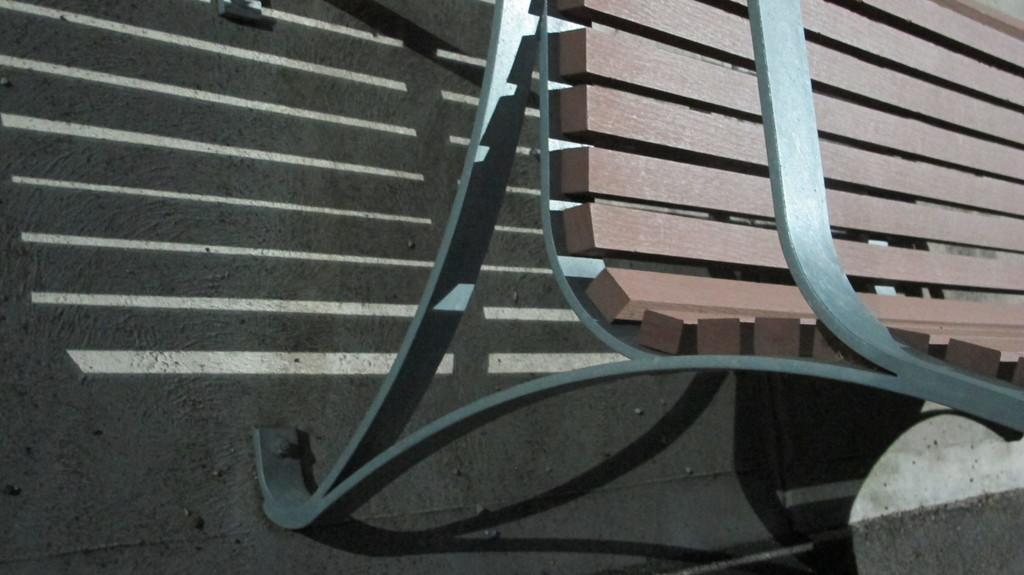What type of furniture is present in the image? There is a bench in the image. Where is the bench located? The bench is on the floor. What colors can be seen on the bench? The bench has brown and grey colors. What type of oatmeal is being served on the bench in the image? There is no oatmeal present in the image; it features a bench with brown and grey colors. 